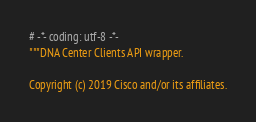<code> <loc_0><loc_0><loc_500><loc_500><_Python_># -*- coding: utf-8 -*-
"""DNA Center Clients API wrapper.

Copyright (c) 2019 Cisco and/or its affiliates.
</code> 